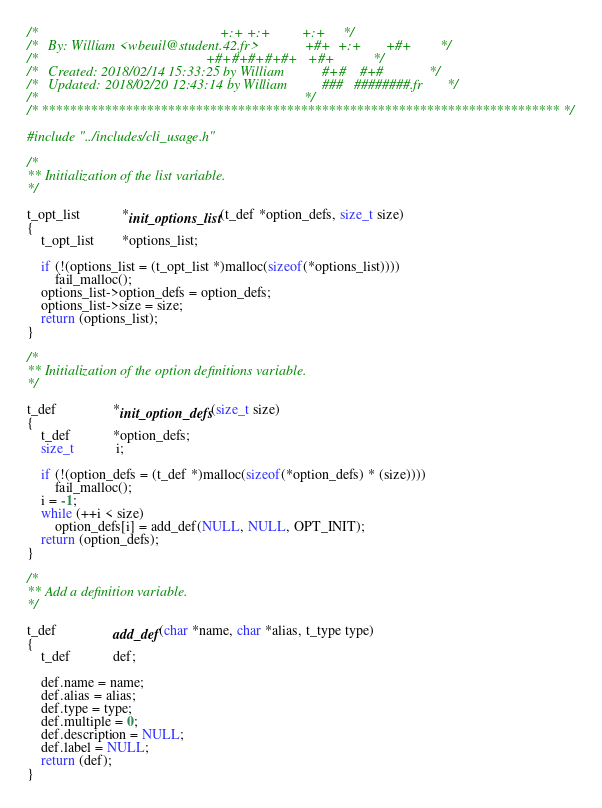<code> <loc_0><loc_0><loc_500><loc_500><_C_>/*                                                    +:+ +:+         +:+     */
/*   By: William <wbeuil@student.42.fr>             +#+  +:+       +#+        */
/*                                                +#+#+#+#+#+   +#+           */
/*   Created: 2018/02/14 15:33:25 by William           #+#    #+#             */
/*   Updated: 2018/02/20 12:43:14 by William          ###   ########.fr       */
/*                                                                            */
/* ************************************************************************** */

#include "../includes/cli_usage.h"

/*
** Initialization of the list variable.
*/

t_opt_list			*init_options_list(t_def *option_defs, size_t size)
{
	t_opt_list		*options_list;

	if (!(options_list = (t_opt_list *)malloc(sizeof(*options_list))))
		fail_malloc();
	options_list->option_defs = option_defs;
	options_list->size = size;
	return (options_list);
}

/*
** Initialization of the option definitions variable.
*/

t_def				*init_option_defs(size_t size)
{
	t_def			*option_defs;
	size_t			i;

	if (!(option_defs = (t_def *)malloc(sizeof(*option_defs) * (size))))
		fail_malloc();
	i = -1;
	while (++i < size)
		option_defs[i] = add_def(NULL, NULL, OPT_INIT);
	return (option_defs);
}

/*
** Add a definition variable.
*/

t_def				add_def(char *name, char *alias, t_type type)
{
	t_def			def;

	def.name = name;
	def.alias = alias;
	def.type = type;
	def.multiple = 0;
	def.description = NULL;
	def.label = NULL;
	return (def);
}
</code> 